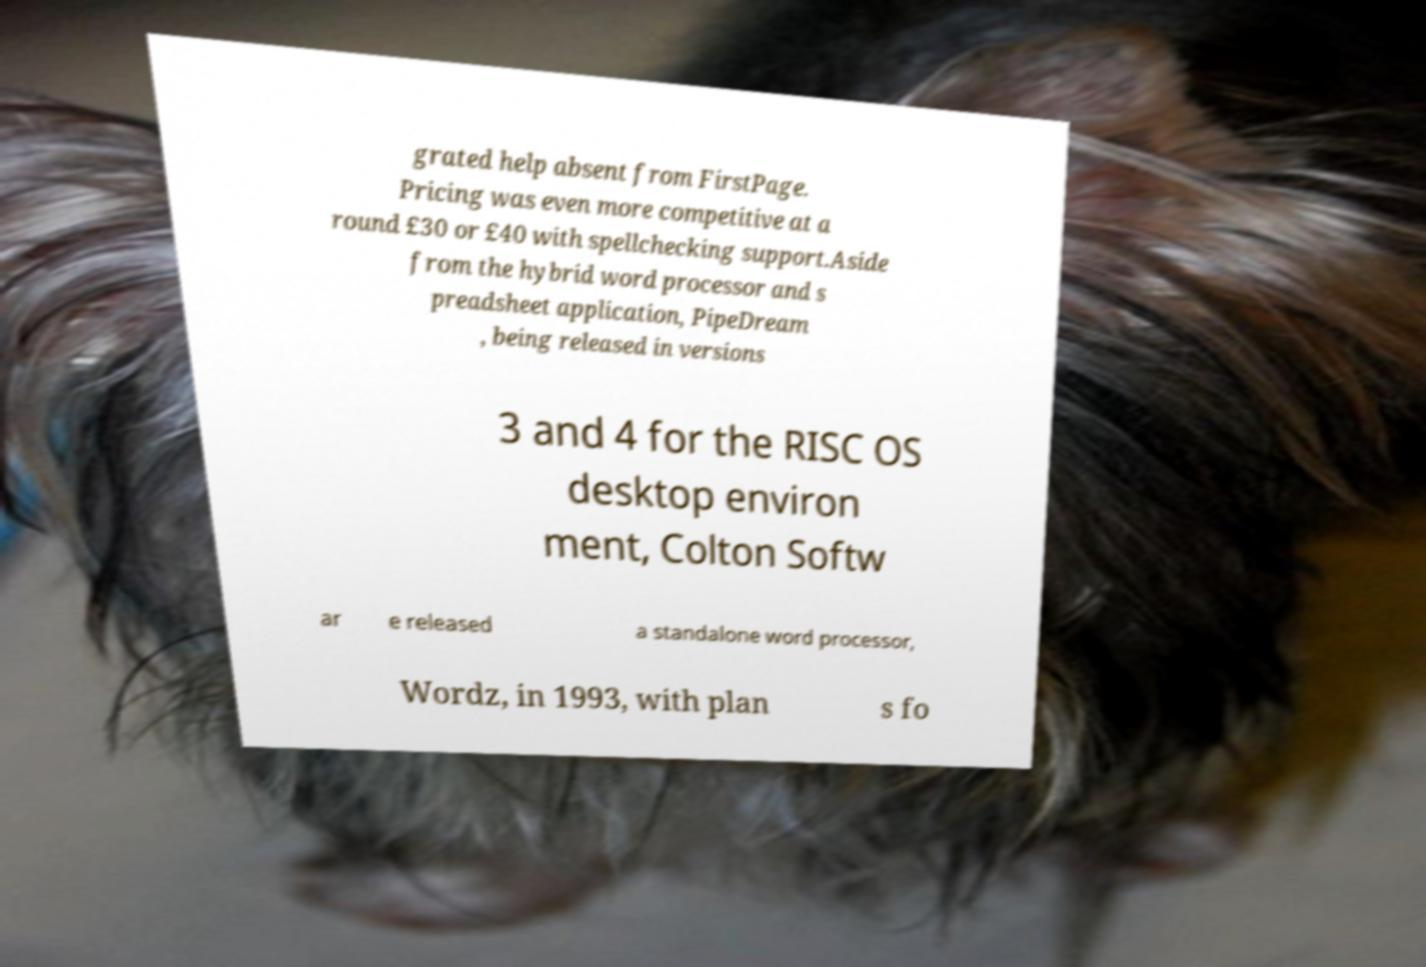For documentation purposes, I need the text within this image transcribed. Could you provide that? grated help absent from FirstPage. Pricing was even more competitive at a round £30 or £40 with spellchecking support.Aside from the hybrid word processor and s preadsheet application, PipeDream , being released in versions 3 and 4 for the RISC OS desktop environ ment, Colton Softw ar e released a standalone word processor, Wordz, in 1993, with plan s fo 